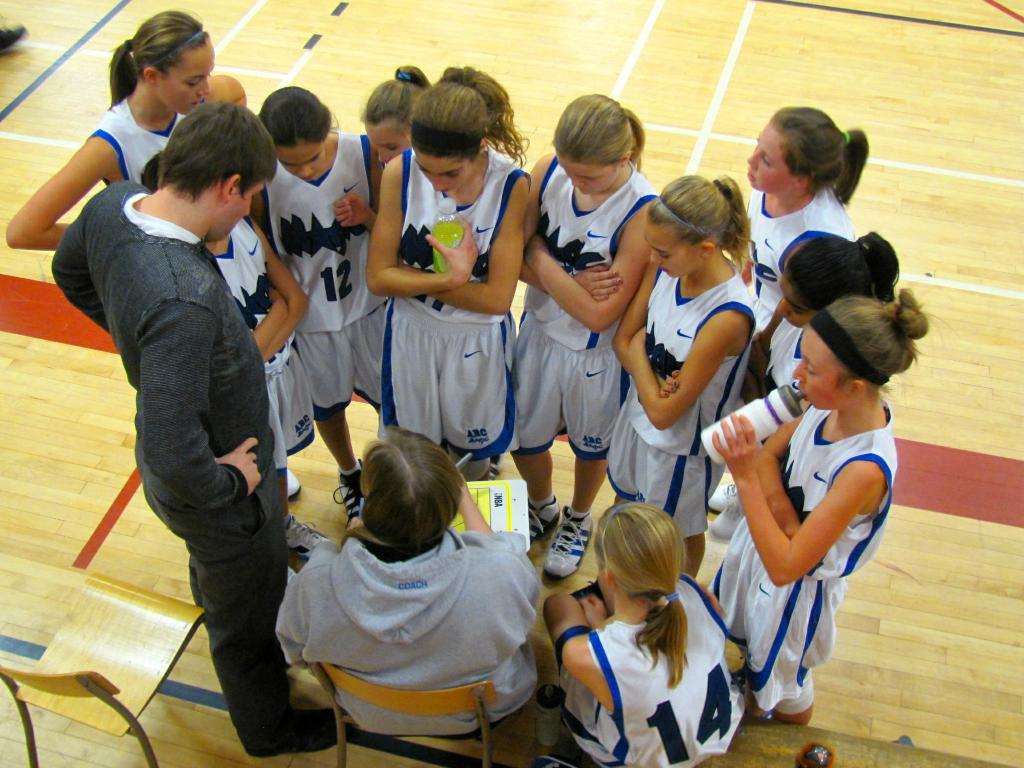Provide a one-sentence caption for the provided image. A girl's basketball team standing in a circle next to their coach, one of them who has a number 12 jersey. 